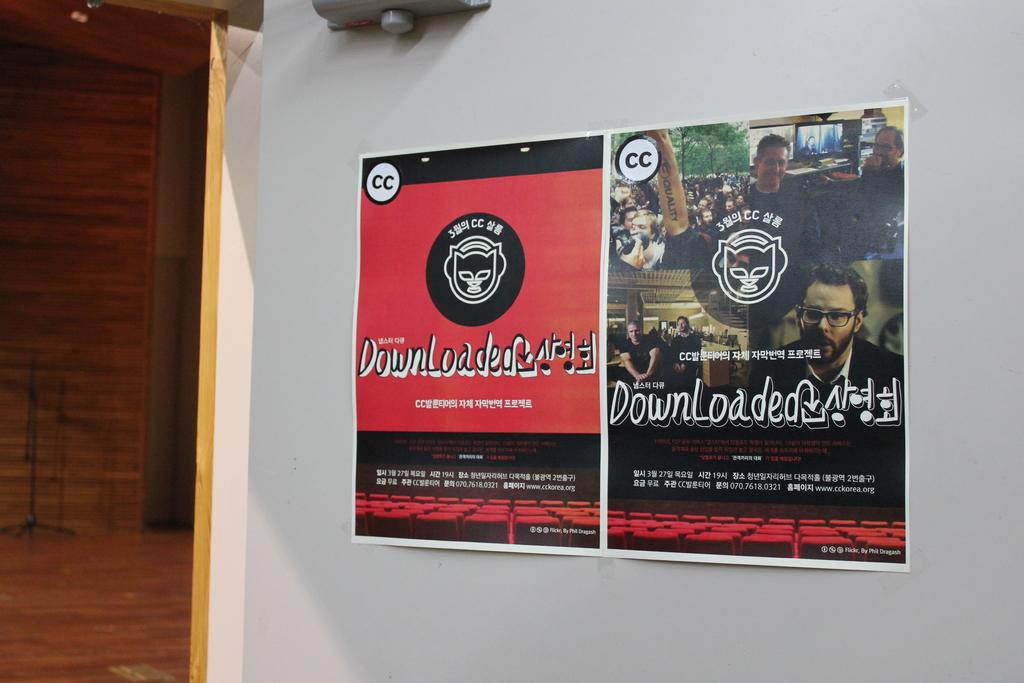<image>
Describe the image concisely. two flyers taped to a wall for downloaded 